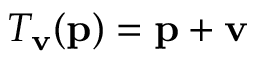<formula> <loc_0><loc_0><loc_500><loc_500>T _ { v } ( p ) = p + v</formula> 